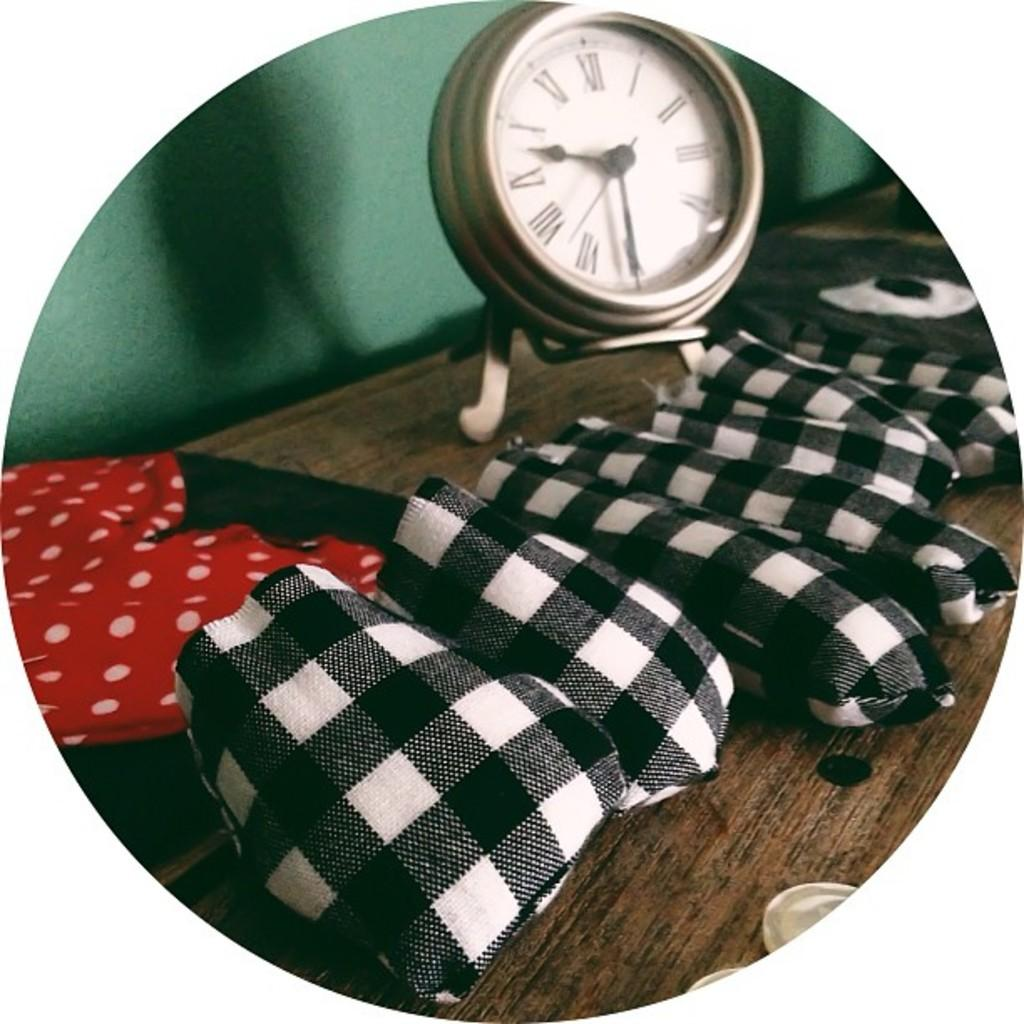<image>
Give a short and clear explanation of the subsequent image. A piece of checked material in  front of a clock which says it is half nine. 